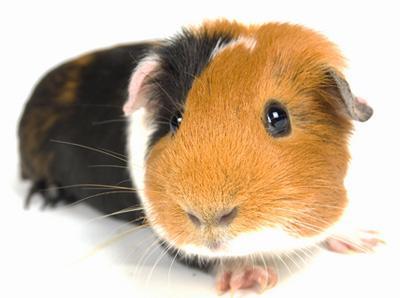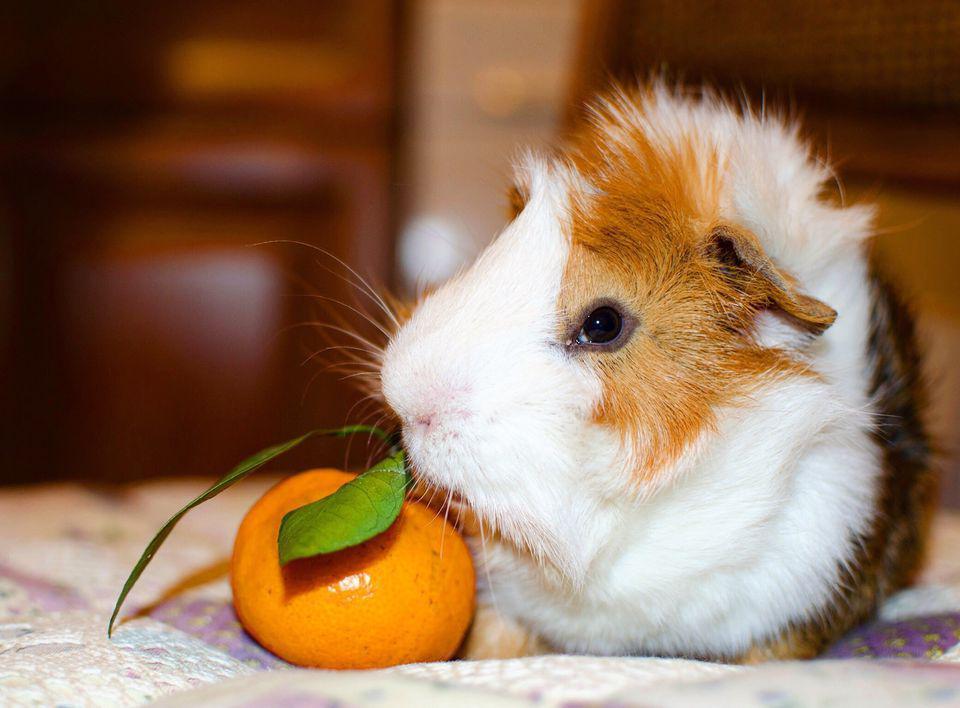The first image is the image on the left, the second image is the image on the right. Given the left and right images, does the statement "A guinea pig with a white snout is facing left." hold true? Answer yes or no. Yes. The first image is the image on the left, the second image is the image on the right. For the images displayed, is the sentence "There are exactly 3 animals." factually correct? Answer yes or no. No. 